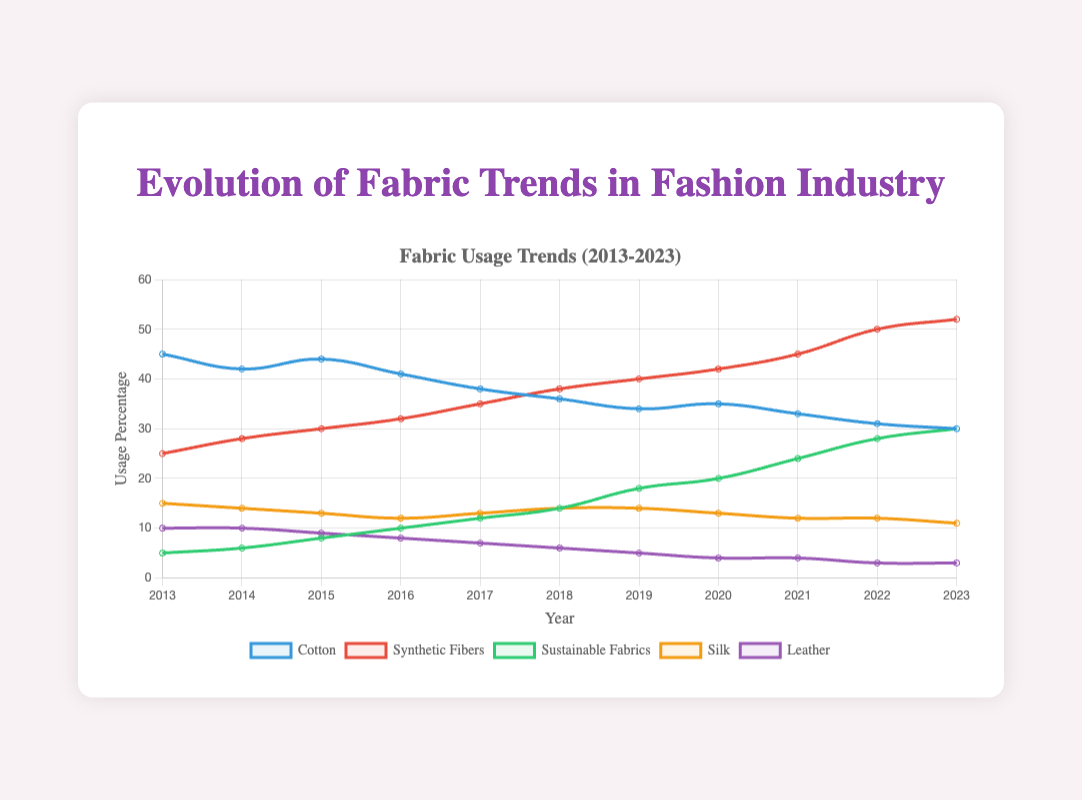Which fabric type had the highest usage in 2023? The chart shows various fabric types over the years. In 2023, synthetic fibers had the highest usage with 52%.
Answer: Synthetic Fibers How did the usage of cotton change from 2013 to 2023? To observe the change, we look at the data points for cotton in 2013 and 2023. It decreased from 45% in 2013 to 30% in 2023.
Answer: Decreased by 15% Between which years did sustainable fabrics see the highest increase in usage? By examining the yearly data points for sustainable fabrics, the highest difference occurs between 2018 and 2019, where the usage went from 14% to 18%.
Answer: 2018 to 2019 How does the trend in leather usage compare to silk usage over the decade? By comparing the curves, leather usage consistently declines from 10% in 2013 to 3% in 2023. Silk has smaller fluctuations but generally trends slightly downward from 15% to 11%.
Answer: Both decline, leather declines more Which fabric had the lowest usage trend in the overall decade? By evaluating the dataset, sustainable fabrics had the lowest initial usage but increased steadily, and leather ended with the lowest usage at 3% by 2023.
Answer: Leather What is the average usage of synthetic fibers from 2013 to 2023? Adding all usage percentages for synthetic fibers (25+28+30+32+35+38+40+42+45+50+52) which equals 417, then dividing by 11 years results in an average of 417/11 = 37.91%.
Answer: 37.91% Which fabrics intersected in their usage trends and where? Observing the dataset, cotton and synthetic fibers intersected in their trends around 2017 where both were approximately at 38%.
Answer: Cotton and Synthetic Fibers in 2017 What's the cumulative change in percentage usage of sustainable fabrics over the decade? Subtract the initial (5%) from the final usage (30%), resulting in a cumulative change of 30% - 5% = 25%.
Answer: 25% How does the visual prominence of synthetic fibers' trend compared to others? The line for synthetic fibers has a steep upward slope and contrasts with others due to its noticeable red color and increased thickness over time, making it visually prominent.
Answer: Most visually prominent What usage percentage do silk and leather together make up in 2023? Adding the usage of silk (11%) and leather (3%) in 2023 gives the combined percentage usage of 11 + 3 = 14%.
Answer: 14% 